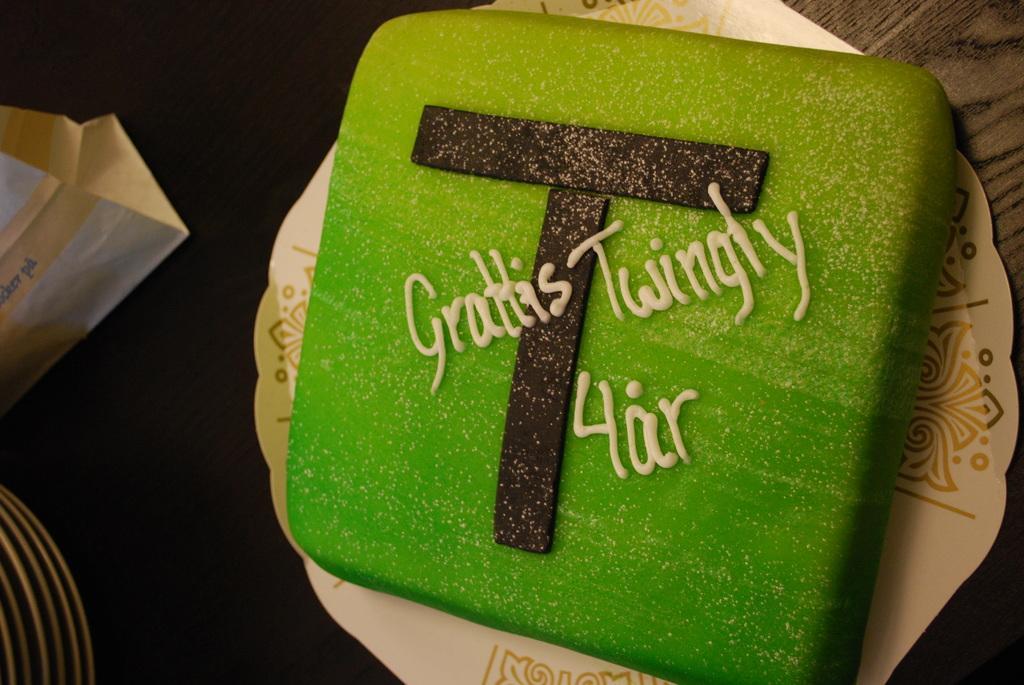In one or two sentences, can you explain what this image depicts? There is a green color cake on the paper plate. At the bottom of the image there is table. To the left side of the image there are few objects. 